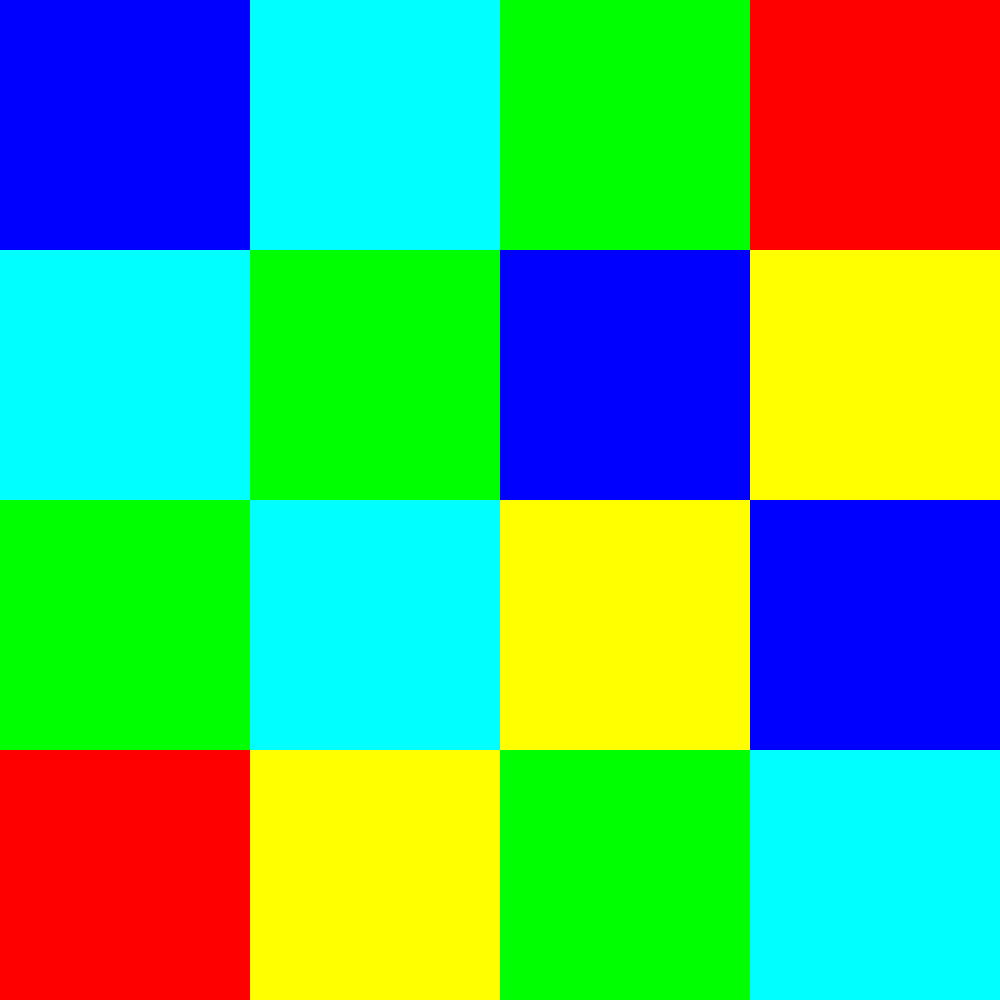Based on the choropleth map showing the distribution of COVID-19 cases among political figures across different regions, which quadrant of the country appears to have the highest concentration of cases, and what implications might this have for public health strategies targeting elderly populations in that area? To answer this question, we need to analyze the choropleth map and interpret its implications:

1. Examine the color scale: The legend shows that darker colors represent higher numbers of COVID-19 cases among political figures.

2. Analyze the map:
   - Northwest (top-left) quadrant: Mostly light colors, indicating fewer cases.
   - Northeast (top-right) quadrant: Mix of light and medium colors, suggesting moderate cases.
   - Southwest (bottom-left) quadrant: Mostly medium colors, indicating moderate to high cases.
   - Southeast (bottom-right) quadrant: Darkest colors, representing the highest concentration of cases.

3. Identify the quadrant with the highest concentration: The Southeast quadrant has the darkest colors, indicating the highest number of COVID-19 cases among political figures.

4. Consider implications for public health strategies targeting the elderly:
   - Political figures often interact with large numbers of people, including the elderly, increasing the risk of transmission.
   - The high concentration of cases in the Southeast suggests a need for more robust public health measures in this region.
   - Strategies could include:
     a) Increased testing and contact tracing for both political figures and elderly populations.
     b) Stricter social distancing measures and mask mandates in public spaces.
     c) Prioritized vaccination efforts for both political figures and the elderly in this region.
     d) Enhanced protection measures for elderly care facilities and retirement communities.
     e) Targeted public health education campaigns about COVID-19 risks and prevention methods.

5. The correlation between cases among political figures and potential spread to the elderly emphasizes the need for comprehensive and region-specific public health approaches.
Answer: Southeast quadrant; intensify protection measures for elderly populations in this region. 